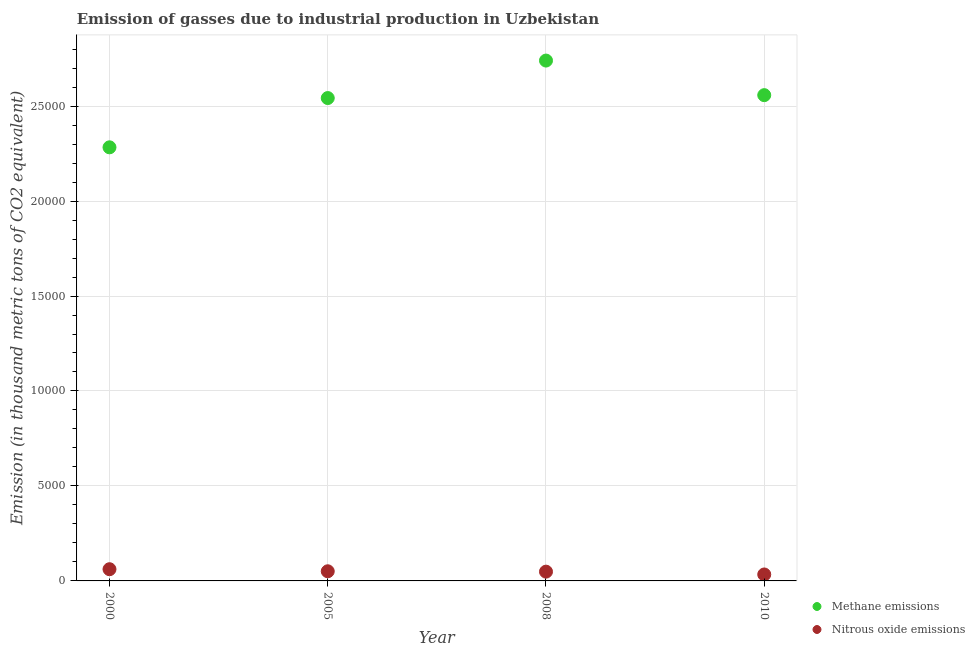How many different coloured dotlines are there?
Provide a short and direct response. 2. Is the number of dotlines equal to the number of legend labels?
Offer a very short reply. Yes. What is the amount of nitrous oxide emissions in 2000?
Your response must be concise. 616.4. Across all years, what is the maximum amount of nitrous oxide emissions?
Keep it short and to the point. 616.4. Across all years, what is the minimum amount of methane emissions?
Ensure brevity in your answer.  2.28e+04. In which year was the amount of methane emissions maximum?
Your answer should be compact. 2008. What is the total amount of nitrous oxide emissions in the graph?
Your answer should be compact. 1952.4. What is the difference between the amount of methane emissions in 2000 and that in 2005?
Provide a succinct answer. -2593.7. What is the difference between the amount of methane emissions in 2000 and the amount of nitrous oxide emissions in 2008?
Offer a terse response. 2.23e+04. What is the average amount of methane emissions per year?
Your response must be concise. 2.53e+04. In the year 2000, what is the difference between the amount of nitrous oxide emissions and amount of methane emissions?
Offer a terse response. -2.22e+04. In how many years, is the amount of nitrous oxide emissions greater than 20000 thousand metric tons?
Provide a short and direct response. 0. What is the ratio of the amount of nitrous oxide emissions in 2000 to that in 2008?
Your response must be concise. 1.26. What is the difference between the highest and the second highest amount of nitrous oxide emissions?
Ensure brevity in your answer.  108.6. What is the difference between the highest and the lowest amount of methane emissions?
Give a very brief answer. 4567.3. In how many years, is the amount of methane emissions greater than the average amount of methane emissions taken over all years?
Offer a terse response. 3. Is the sum of the amount of nitrous oxide emissions in 2000 and 2008 greater than the maximum amount of methane emissions across all years?
Provide a succinct answer. No. Is the amount of nitrous oxide emissions strictly less than the amount of methane emissions over the years?
Give a very brief answer. Yes. How many dotlines are there?
Provide a short and direct response. 2. What is the difference between two consecutive major ticks on the Y-axis?
Your response must be concise. 5000. Does the graph contain grids?
Offer a terse response. Yes. What is the title of the graph?
Ensure brevity in your answer.  Emission of gasses due to industrial production in Uzbekistan. What is the label or title of the Y-axis?
Your answer should be very brief. Emission (in thousand metric tons of CO2 equivalent). What is the Emission (in thousand metric tons of CO2 equivalent) of Methane emissions in 2000?
Provide a short and direct response. 2.28e+04. What is the Emission (in thousand metric tons of CO2 equivalent) of Nitrous oxide emissions in 2000?
Your answer should be compact. 616.4. What is the Emission (in thousand metric tons of CO2 equivalent) in Methane emissions in 2005?
Keep it short and to the point. 2.54e+04. What is the Emission (in thousand metric tons of CO2 equivalent) of Nitrous oxide emissions in 2005?
Your answer should be compact. 507.8. What is the Emission (in thousand metric tons of CO2 equivalent) in Methane emissions in 2008?
Your answer should be very brief. 2.74e+04. What is the Emission (in thousand metric tons of CO2 equivalent) of Nitrous oxide emissions in 2008?
Your response must be concise. 488.2. What is the Emission (in thousand metric tons of CO2 equivalent) in Methane emissions in 2010?
Give a very brief answer. 2.56e+04. What is the Emission (in thousand metric tons of CO2 equivalent) of Nitrous oxide emissions in 2010?
Your answer should be very brief. 340. Across all years, what is the maximum Emission (in thousand metric tons of CO2 equivalent) of Methane emissions?
Keep it short and to the point. 2.74e+04. Across all years, what is the maximum Emission (in thousand metric tons of CO2 equivalent) in Nitrous oxide emissions?
Your response must be concise. 616.4. Across all years, what is the minimum Emission (in thousand metric tons of CO2 equivalent) in Methane emissions?
Offer a terse response. 2.28e+04. Across all years, what is the minimum Emission (in thousand metric tons of CO2 equivalent) of Nitrous oxide emissions?
Ensure brevity in your answer.  340. What is the total Emission (in thousand metric tons of CO2 equivalent) in Methane emissions in the graph?
Offer a very short reply. 1.01e+05. What is the total Emission (in thousand metric tons of CO2 equivalent) in Nitrous oxide emissions in the graph?
Provide a succinct answer. 1952.4. What is the difference between the Emission (in thousand metric tons of CO2 equivalent) in Methane emissions in 2000 and that in 2005?
Your answer should be compact. -2593.7. What is the difference between the Emission (in thousand metric tons of CO2 equivalent) of Nitrous oxide emissions in 2000 and that in 2005?
Make the answer very short. 108.6. What is the difference between the Emission (in thousand metric tons of CO2 equivalent) in Methane emissions in 2000 and that in 2008?
Offer a terse response. -4567.3. What is the difference between the Emission (in thousand metric tons of CO2 equivalent) of Nitrous oxide emissions in 2000 and that in 2008?
Offer a terse response. 128.2. What is the difference between the Emission (in thousand metric tons of CO2 equivalent) of Methane emissions in 2000 and that in 2010?
Keep it short and to the point. -2746.8. What is the difference between the Emission (in thousand metric tons of CO2 equivalent) in Nitrous oxide emissions in 2000 and that in 2010?
Make the answer very short. 276.4. What is the difference between the Emission (in thousand metric tons of CO2 equivalent) of Methane emissions in 2005 and that in 2008?
Ensure brevity in your answer.  -1973.6. What is the difference between the Emission (in thousand metric tons of CO2 equivalent) in Nitrous oxide emissions in 2005 and that in 2008?
Offer a terse response. 19.6. What is the difference between the Emission (in thousand metric tons of CO2 equivalent) of Methane emissions in 2005 and that in 2010?
Your response must be concise. -153.1. What is the difference between the Emission (in thousand metric tons of CO2 equivalent) of Nitrous oxide emissions in 2005 and that in 2010?
Provide a short and direct response. 167.8. What is the difference between the Emission (in thousand metric tons of CO2 equivalent) in Methane emissions in 2008 and that in 2010?
Keep it short and to the point. 1820.5. What is the difference between the Emission (in thousand metric tons of CO2 equivalent) in Nitrous oxide emissions in 2008 and that in 2010?
Give a very brief answer. 148.2. What is the difference between the Emission (in thousand metric tons of CO2 equivalent) of Methane emissions in 2000 and the Emission (in thousand metric tons of CO2 equivalent) of Nitrous oxide emissions in 2005?
Provide a succinct answer. 2.23e+04. What is the difference between the Emission (in thousand metric tons of CO2 equivalent) in Methane emissions in 2000 and the Emission (in thousand metric tons of CO2 equivalent) in Nitrous oxide emissions in 2008?
Ensure brevity in your answer.  2.23e+04. What is the difference between the Emission (in thousand metric tons of CO2 equivalent) in Methane emissions in 2000 and the Emission (in thousand metric tons of CO2 equivalent) in Nitrous oxide emissions in 2010?
Your answer should be very brief. 2.25e+04. What is the difference between the Emission (in thousand metric tons of CO2 equivalent) of Methane emissions in 2005 and the Emission (in thousand metric tons of CO2 equivalent) of Nitrous oxide emissions in 2008?
Your answer should be very brief. 2.49e+04. What is the difference between the Emission (in thousand metric tons of CO2 equivalent) of Methane emissions in 2005 and the Emission (in thousand metric tons of CO2 equivalent) of Nitrous oxide emissions in 2010?
Offer a very short reply. 2.51e+04. What is the difference between the Emission (in thousand metric tons of CO2 equivalent) of Methane emissions in 2008 and the Emission (in thousand metric tons of CO2 equivalent) of Nitrous oxide emissions in 2010?
Offer a terse response. 2.71e+04. What is the average Emission (in thousand metric tons of CO2 equivalent) in Methane emissions per year?
Provide a succinct answer. 2.53e+04. What is the average Emission (in thousand metric tons of CO2 equivalent) of Nitrous oxide emissions per year?
Provide a short and direct response. 488.1. In the year 2000, what is the difference between the Emission (in thousand metric tons of CO2 equivalent) in Methane emissions and Emission (in thousand metric tons of CO2 equivalent) in Nitrous oxide emissions?
Ensure brevity in your answer.  2.22e+04. In the year 2005, what is the difference between the Emission (in thousand metric tons of CO2 equivalent) in Methane emissions and Emission (in thousand metric tons of CO2 equivalent) in Nitrous oxide emissions?
Offer a very short reply. 2.49e+04. In the year 2008, what is the difference between the Emission (in thousand metric tons of CO2 equivalent) in Methane emissions and Emission (in thousand metric tons of CO2 equivalent) in Nitrous oxide emissions?
Keep it short and to the point. 2.69e+04. In the year 2010, what is the difference between the Emission (in thousand metric tons of CO2 equivalent) of Methane emissions and Emission (in thousand metric tons of CO2 equivalent) of Nitrous oxide emissions?
Keep it short and to the point. 2.52e+04. What is the ratio of the Emission (in thousand metric tons of CO2 equivalent) of Methane emissions in 2000 to that in 2005?
Your response must be concise. 0.9. What is the ratio of the Emission (in thousand metric tons of CO2 equivalent) in Nitrous oxide emissions in 2000 to that in 2005?
Offer a terse response. 1.21. What is the ratio of the Emission (in thousand metric tons of CO2 equivalent) of Methane emissions in 2000 to that in 2008?
Provide a short and direct response. 0.83. What is the ratio of the Emission (in thousand metric tons of CO2 equivalent) in Nitrous oxide emissions in 2000 to that in 2008?
Provide a succinct answer. 1.26. What is the ratio of the Emission (in thousand metric tons of CO2 equivalent) in Methane emissions in 2000 to that in 2010?
Offer a very short reply. 0.89. What is the ratio of the Emission (in thousand metric tons of CO2 equivalent) in Nitrous oxide emissions in 2000 to that in 2010?
Your answer should be compact. 1.81. What is the ratio of the Emission (in thousand metric tons of CO2 equivalent) in Methane emissions in 2005 to that in 2008?
Make the answer very short. 0.93. What is the ratio of the Emission (in thousand metric tons of CO2 equivalent) in Nitrous oxide emissions in 2005 to that in 2008?
Your answer should be very brief. 1.04. What is the ratio of the Emission (in thousand metric tons of CO2 equivalent) in Nitrous oxide emissions in 2005 to that in 2010?
Your answer should be compact. 1.49. What is the ratio of the Emission (in thousand metric tons of CO2 equivalent) of Methane emissions in 2008 to that in 2010?
Provide a succinct answer. 1.07. What is the ratio of the Emission (in thousand metric tons of CO2 equivalent) in Nitrous oxide emissions in 2008 to that in 2010?
Offer a very short reply. 1.44. What is the difference between the highest and the second highest Emission (in thousand metric tons of CO2 equivalent) of Methane emissions?
Provide a succinct answer. 1820.5. What is the difference between the highest and the second highest Emission (in thousand metric tons of CO2 equivalent) of Nitrous oxide emissions?
Make the answer very short. 108.6. What is the difference between the highest and the lowest Emission (in thousand metric tons of CO2 equivalent) of Methane emissions?
Your answer should be compact. 4567.3. What is the difference between the highest and the lowest Emission (in thousand metric tons of CO2 equivalent) of Nitrous oxide emissions?
Keep it short and to the point. 276.4. 